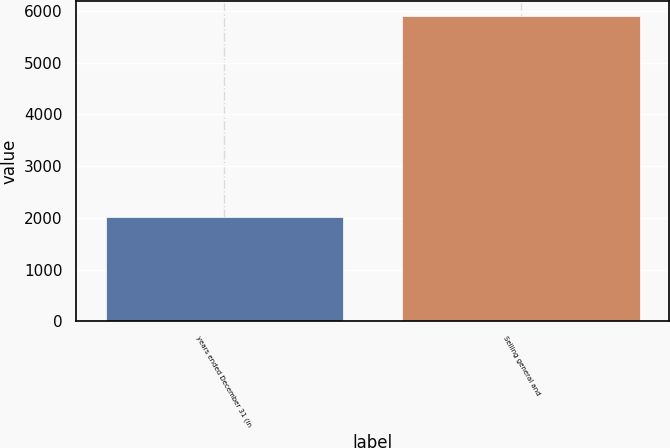Convert chart. <chart><loc_0><loc_0><loc_500><loc_500><bar_chart><fcel>years ended December 31 (in<fcel>Selling general and<nl><fcel>2011<fcel>5894<nl></chart> 